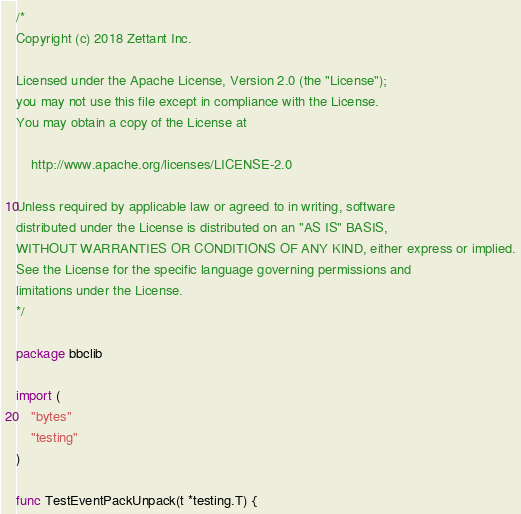Convert code to text. <code><loc_0><loc_0><loc_500><loc_500><_Go_>/*
Copyright (c) 2018 Zettant Inc.

Licensed under the Apache License, Version 2.0 (the "License");
you may not use this file except in compliance with the License.
You may obtain a copy of the License at

    http://www.apache.org/licenses/LICENSE-2.0

Unless required by applicable law or agreed to in writing, software
distributed under the License is distributed on an "AS IS" BASIS,
WITHOUT WARRANTIES OR CONDITIONS OF ANY KIND, either express or implied.
See the License for the specific language governing permissions and
limitations under the License.
*/

package bbclib

import (
	"bytes"
	"testing"
)

func TestEventPackUnpack(t *testing.T) {</code> 